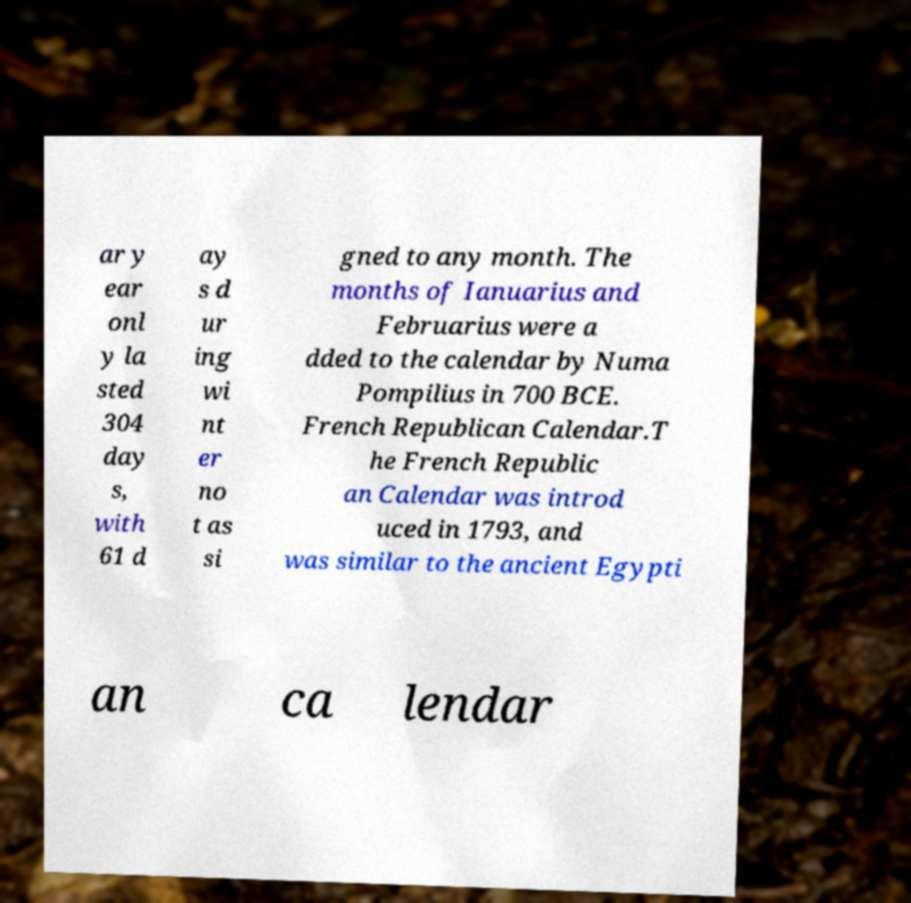What messages or text are displayed in this image? I need them in a readable, typed format. ar y ear onl y la sted 304 day s, with 61 d ay s d ur ing wi nt er no t as si gned to any month. The months of Ianuarius and Februarius were a dded to the calendar by Numa Pompilius in 700 BCE. French Republican Calendar.T he French Republic an Calendar was introd uced in 1793, and was similar to the ancient Egypti an ca lendar 